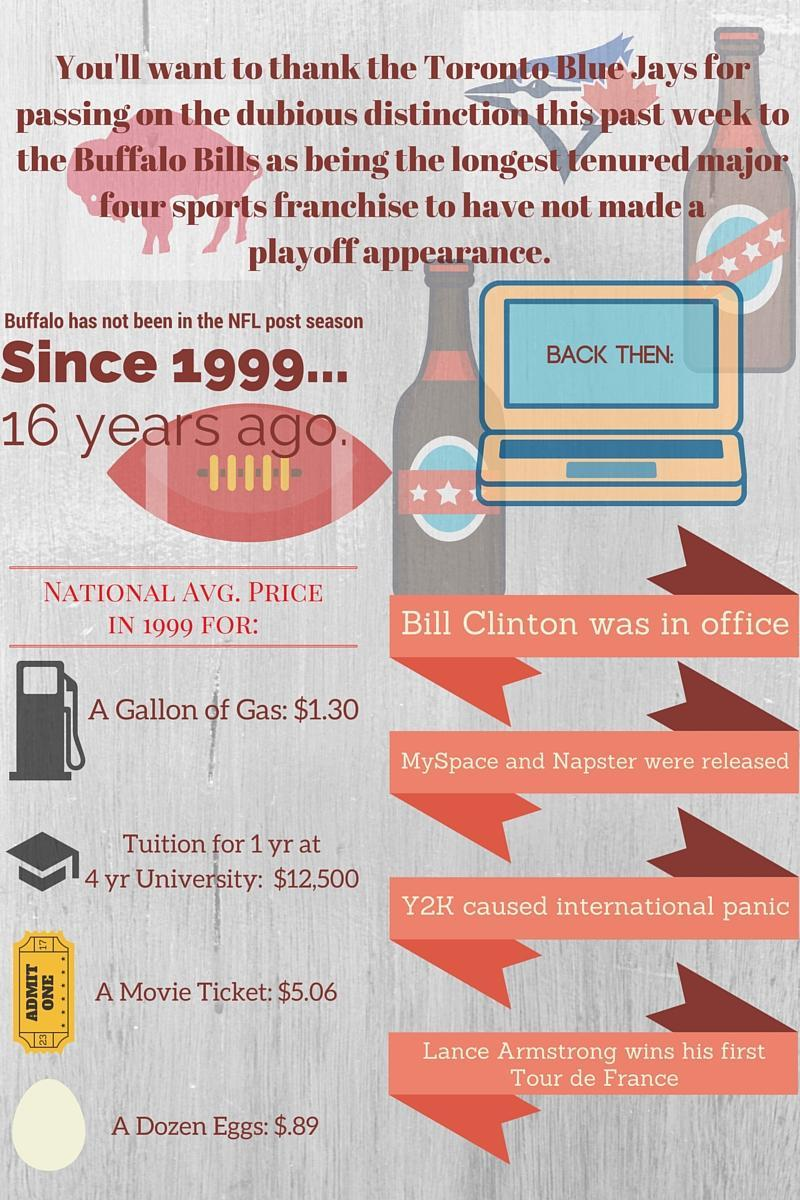when was MySpace and Napster released
Answer the question with a short phrase. 1999 What is written on the movie ticket admin one what is written on the computer screen back then: WHen in Lance Armstrong win his first tour de france 1999 WHich year did Y2K cause international panic 1999 who was the american president in 1999 bill clinton 